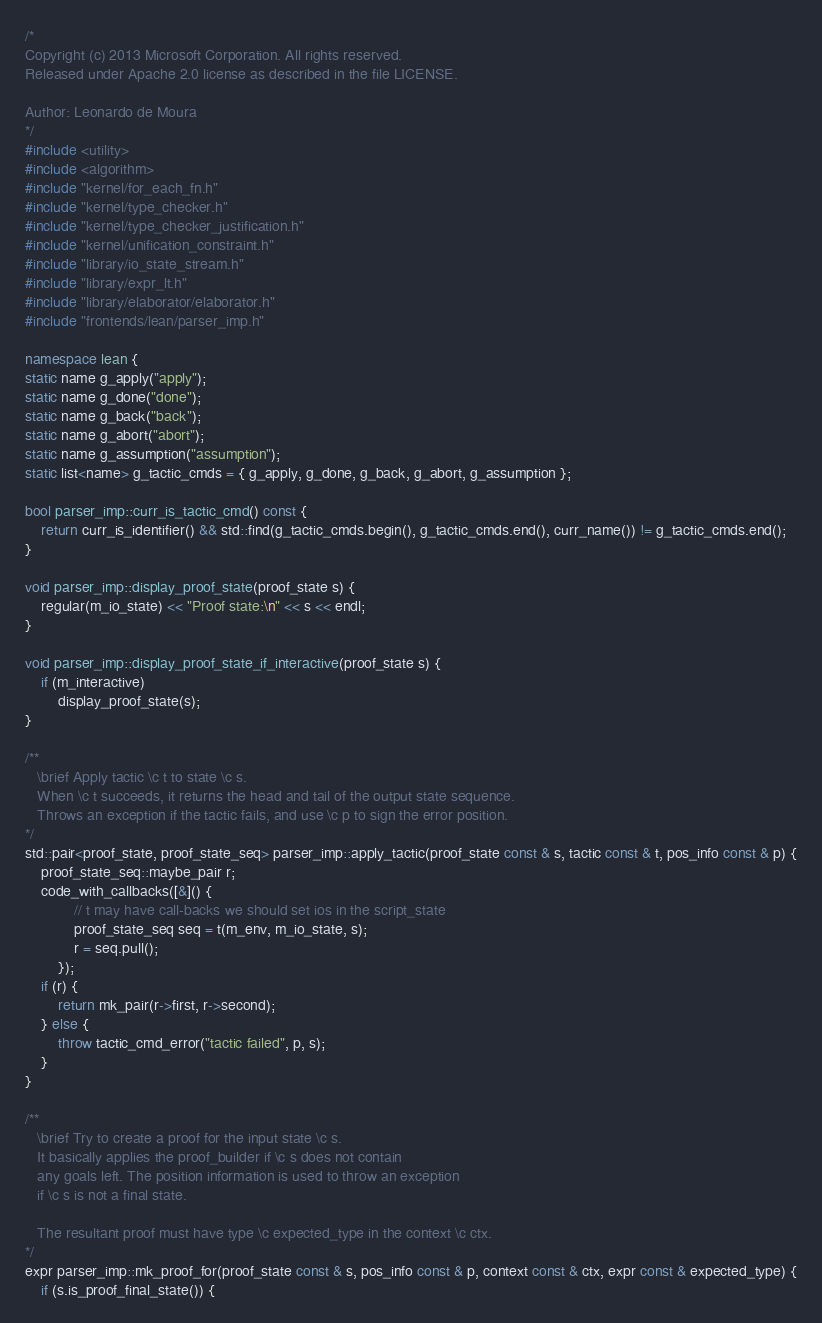<code> <loc_0><loc_0><loc_500><loc_500><_C++_>/*
Copyright (c) 2013 Microsoft Corporation. All rights reserved.
Released under Apache 2.0 license as described in the file LICENSE.

Author: Leonardo de Moura
*/
#include <utility>
#include <algorithm>
#include "kernel/for_each_fn.h"
#include "kernel/type_checker.h"
#include "kernel/type_checker_justification.h"
#include "kernel/unification_constraint.h"
#include "library/io_state_stream.h"
#include "library/expr_lt.h"
#include "library/elaborator/elaborator.h"
#include "frontends/lean/parser_imp.h"

namespace lean {
static name g_apply("apply");
static name g_done("done");
static name g_back("back");
static name g_abort("abort");
static name g_assumption("assumption");
static list<name> g_tactic_cmds = { g_apply, g_done, g_back, g_abort, g_assumption };

bool parser_imp::curr_is_tactic_cmd() const {
    return curr_is_identifier() && std::find(g_tactic_cmds.begin(), g_tactic_cmds.end(), curr_name()) != g_tactic_cmds.end();
}

void parser_imp::display_proof_state(proof_state s) {
    regular(m_io_state) << "Proof state:\n" << s << endl;
}

void parser_imp::display_proof_state_if_interactive(proof_state s) {
    if (m_interactive)
        display_proof_state(s);
}

/**
   \brief Apply tactic \c t to state \c s.
   When \c t succeeds, it returns the head and tail of the output state sequence.
   Throws an exception if the tactic fails, and use \c p to sign the error position.
*/
std::pair<proof_state, proof_state_seq> parser_imp::apply_tactic(proof_state const & s, tactic const & t, pos_info const & p) {
    proof_state_seq::maybe_pair r;
    code_with_callbacks([&]() {
            // t may have call-backs we should set ios in the script_state
            proof_state_seq seq = t(m_env, m_io_state, s);
            r = seq.pull();
        });
    if (r) {
        return mk_pair(r->first, r->second);
    } else {
        throw tactic_cmd_error("tactic failed", p, s);
    }
}

/**
   \brief Try to create a proof for the input state \c s.
   It basically applies the proof_builder if \c s does not contain
   any goals left. The position information is used to throw an exception
   if \c s is not a final state.

   The resultant proof must have type \c expected_type in the context \c ctx.
*/
expr parser_imp::mk_proof_for(proof_state const & s, pos_info const & p, context const & ctx, expr const & expected_type) {
    if (s.is_proof_final_state()) {</code> 